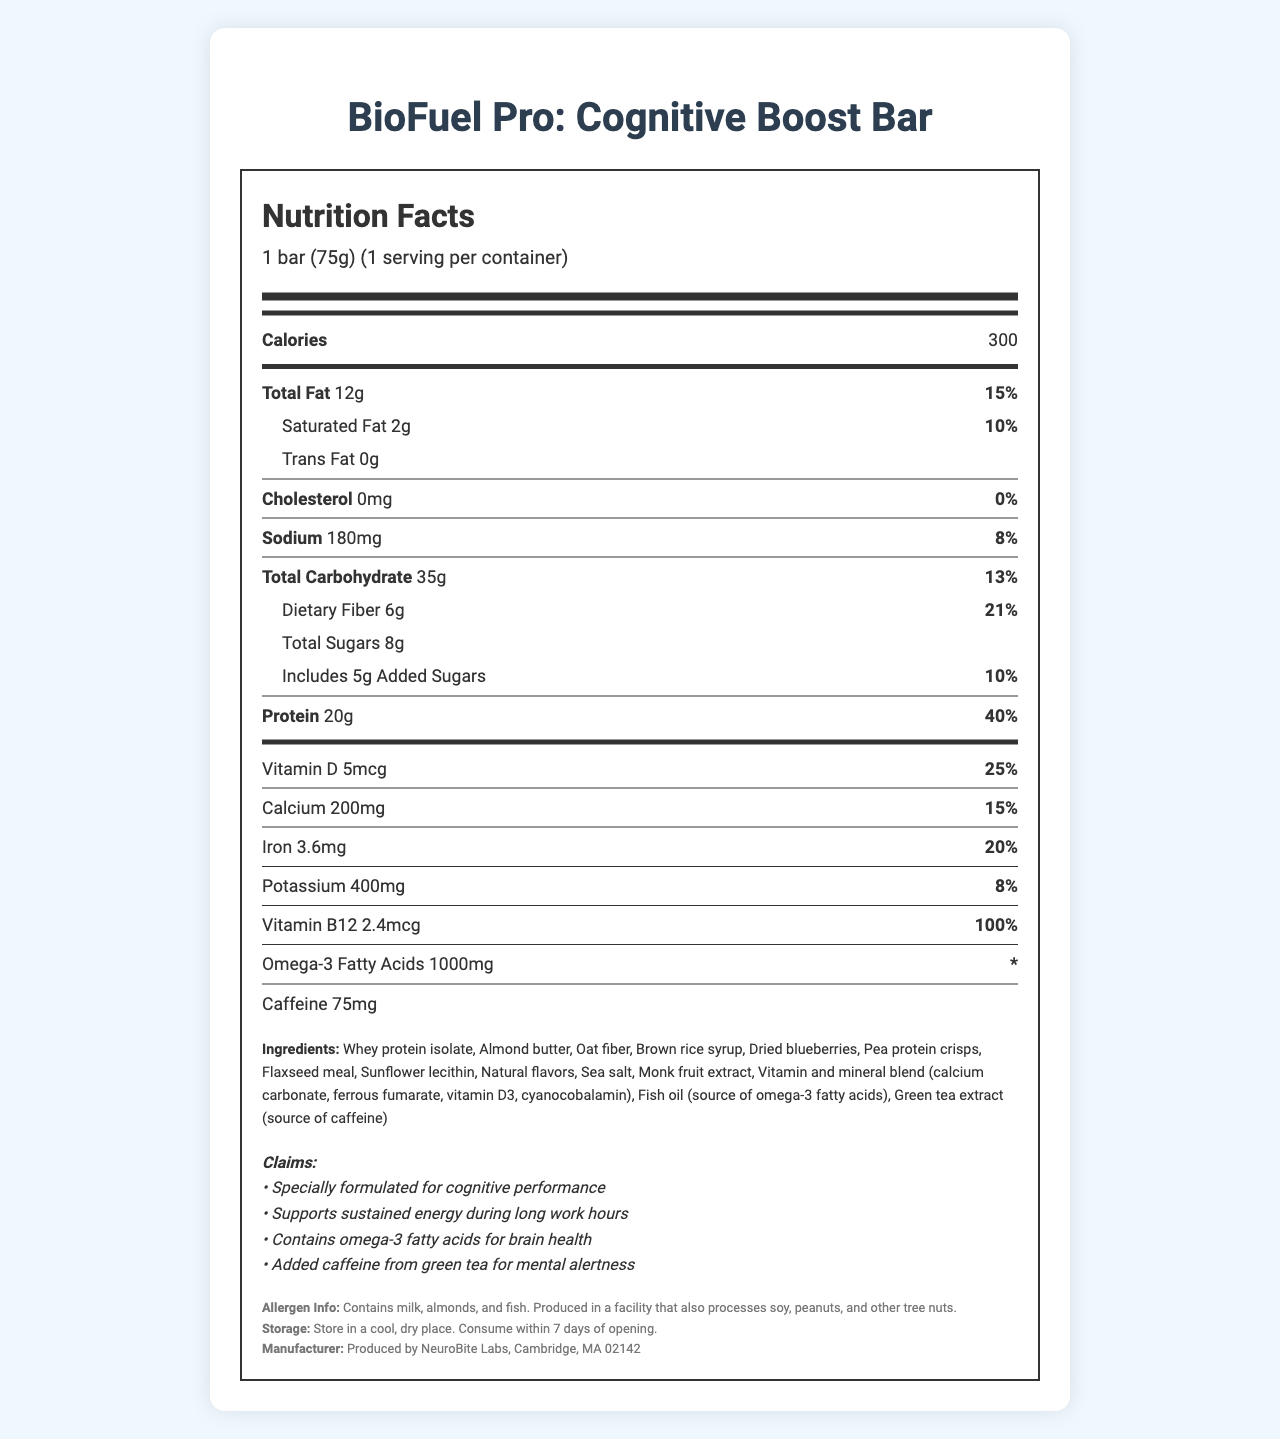what is the serving size of the BioFuel Pro: Cognitive Boost Bar? The serving size is explicitly mentioned in the nutrition label as "1 bar (75g)".
Answer: 1 bar (75g) what is the amount of protein per serving? The protein amount per serving is listed as "20g" in the document.
Answer: 20g how much caffeine does the bar contain? The document states that the bar contains 75mg of caffeine.
Answer: 75mg which vitamin is present at 100% of the daily value per serving? The document lists Vitamin B12 as being present at 100% of the daily value.
Answer: Vitamin B12 what is the calorie content per serving? The label shows that each serving contains 300 calories.
Answer: 300 calories how many grams of total fat are in each bar? A. 10g B. 12g C. 15g D. 20g The document indicates that there are 12g of total fat in each bar, so option B is correct.
Answer: B. 12g which of the following is NOT an ingredient in the bar? i. Whey protein isolate ii. Almond butter iii. Soy protein iv. Dried blueberries The given ingredients in the document include whey protein isolate, almond butter, and dried blueberries, but not soy protein.
Answer: iii. Soy protein is the bar suitable for someone with a peanut allergy? The allergen info states that the bar is produced in a facility that also processes peanuts, so it may not be safe for someone with a peanut allergy.
Answer: No summarize the main purpose of this document. The document is a comprehensive nutrition label highlighting the dietary content, health benefits, and considerations for the BioFuel Pro: Cognitive Boost Bar.
Answer: The document provides detailed nutrition facts for the BioFuel Pro: Cognitive Boost Bar, tailored for bioinformatics professionals working long hours. It includes information on serving size, calories, macronutrients, vitamins and minerals, ingredients, allergen information, storage instructions, and claims about cognitive and energy benefits. what is the net weight of the entire container? The document specifies the serving size (1 bar) and servings per container (1), but it does not provide the overall weight of the container.
Answer: Cannot be determined how much of the daily value of calcium does one bar provide? The document lists that one bar provides 200mg of calcium, which is 15% of the daily value.
Answer: 15% what mineral content in the bar supports iron levels? The document shows that the bar contains 3.6mg of iron, which is 20% of the daily value, supporting iron levels.
Answer: Iron given the ingredients, which food allergens are explicitly mentioned? A. Milk B. Almonds C. Fish D. All of the above The allergen information states that the product contains milk, almonds, and fish, making option D correct.
Answer: D. All of the above 